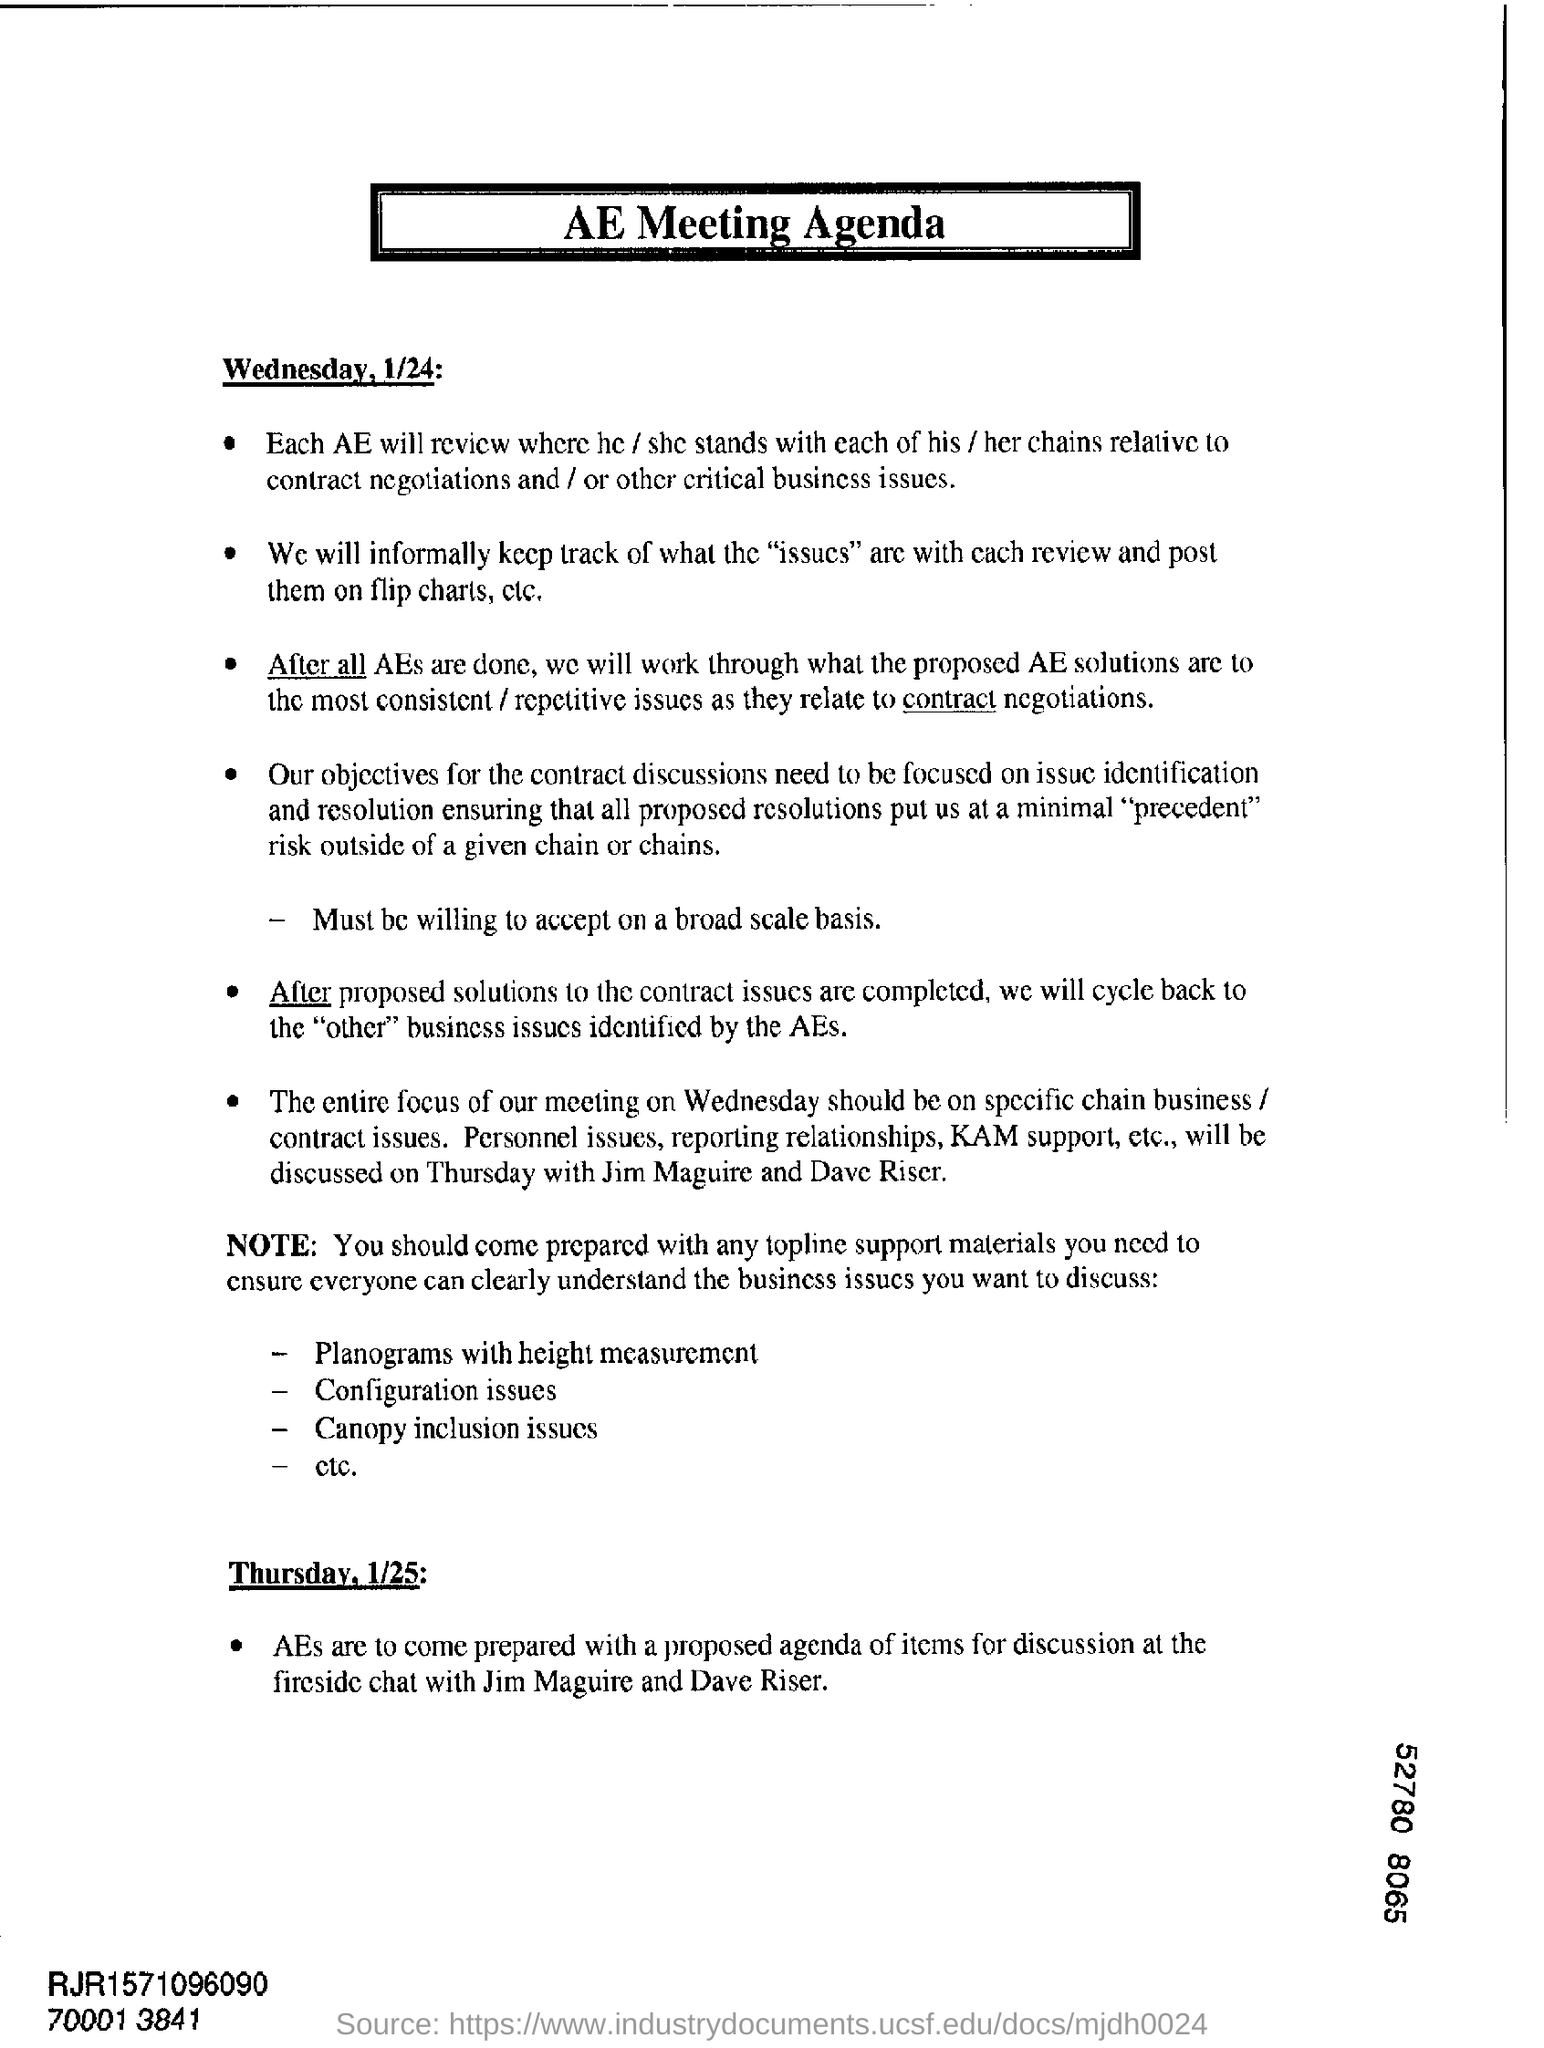Indicate a few pertinent items in this graphic. The first date mentioned is Wednesday, January 24. This agenda is for the meeting of the Association of Engineers. 